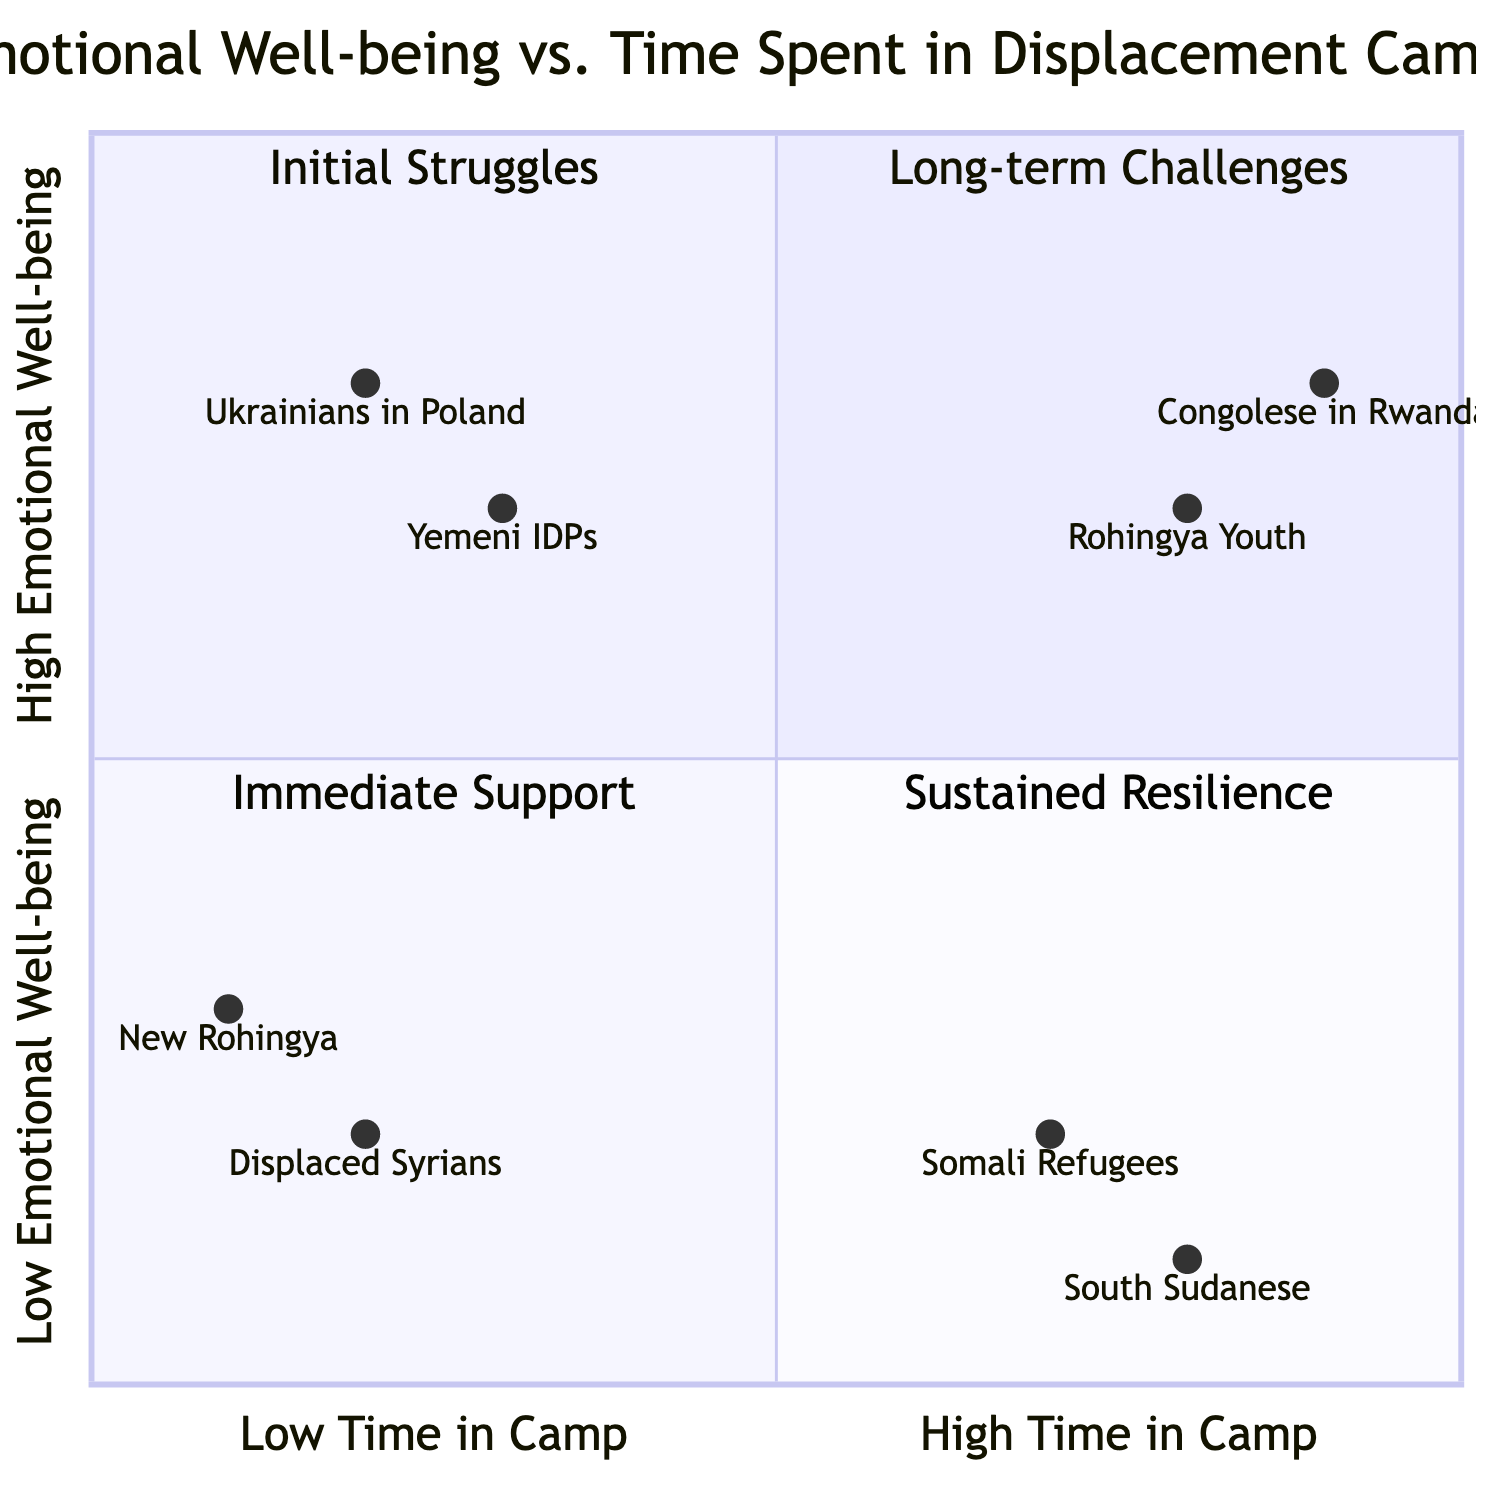What is the emotional well-being of South Sudanese in the camps? The emotional well-being of South Sudanese in the camps is categorized as low, as represented in the diagram. They are positioned in the lower segment of the chart, indicating that they experience significant challenges to their emotional health.
Answer: Low How long are Somali refugees typically in camps, based on the chart? Somali refugees are indicated in the chart as being in camps for a longer period, as their position is towards the right segment of the diagram representing high time spent in camps.
Answer: Long Which entity has high emotional well-being and short time in the camp? The diagram shows that Yemeni Internally Displaced Persons are situated in the quadrant that represents high emotional well-being and short time spent in the camp, reflecting their circumstances.
Answer: Yemeni Internally Displaced Persons What aspect contributes to the emotional resilience of Ukrainian displaced individuals? The aspect contributing to their emotional resilience, as per the chart, is strong community support which is highlighted in the top-right quadrant where they are positioned.
Answer: Community Support How many entities are categorized under low emotional well-being? By examining the quadrants, it is evident that there are four entities categorized under low emotional well-being, found in the lower quadrants of the chart.
Answer: Four What correlation is observed between time spent in the camp and emotional well-being for Congolese refugees? Congolese refugees demonstrate a positive correlation, as they are in the upper segment of the chart while also spending a long time in the camp, suggesting that long-term support has fostered emotional well-being.
Answer: Positive correlation Which aspect helps maintain emotional well-being for Rohingya youth? The chart indicates that continuous access to educational opportunities is the key aspect that helps maintain the emotional well-being of Rohingya youth, shown in the quadrant for high emotional well-being and long time in camp.
Answer: Educational Opportunities What is the location of new arrivals in Rohingya camps on the diagram? New arrivals in Rohingya camps are located in the lower-left quadrant of the diagram, indicating they face initial struggles and low emotional well-being.
Answer: Lower-left quadrant Which group falls into the quadrant representing sustained resilience? The group that falls into the quadrant representing sustained resilience, characterized by high emotional well-being and long time in camp, is Congolese refugees in Rwanda.
Answer: Congolese Refugees in Rwanda 